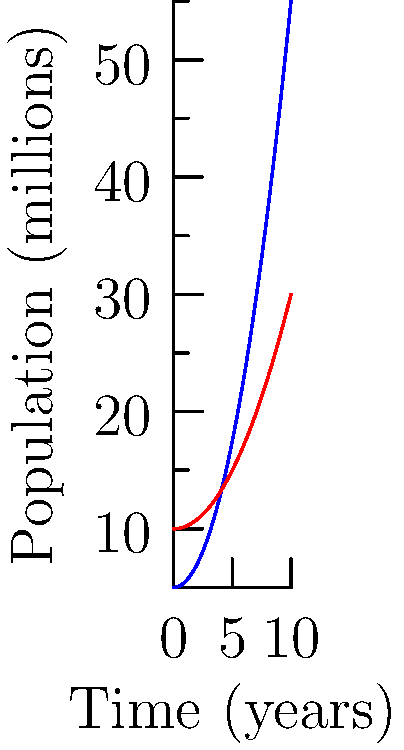The graph shows the population growth of two countries over a 10-year period. Country A's population function is given by $P_1(t) = 5 + 0.5t^2$, and Country B's is $P_2(t) = 10 + 0.2t^2$, where $t$ is time in years and $P$ is population in millions. Calculate the difference in total population growth between Country A and Country B over the 10-year period. To solve this problem, we need to:

1. Calculate the total population growth for each country.
2. Find the difference between these growths.

For each country, the total population growth is the area under its curve from $t=0$ to $t=10$.

For Country A:
1. The area is given by the definite integral: 
   $$\int_0^{10} (5 + 0.5t^2) dt$$
2. Integrate: 
   $$[5t + \frac{0.5t^3}{3}]_0^{10}$$
3. Evaluate: 
   $$(50 + \frac{500}{3}) - (0 + 0) = 50 + \frac{500}{3} = \frac{650}{3}$$

For Country B:
1. The area is given by the definite integral: 
   $$\int_0^{10} (10 + 0.2t^2) dt$$
2. Integrate: 
   $$[10t + \frac{0.2t^3}{3}]_0^{10}$$
3. Evaluate: 
   $$(100 + \frac{200}{3}) - (0 + 0) = 100 + \frac{200}{3} = \frac{400}{3}$$

The difference in growth:
$$\frac{650}{3} - \frac{400}{3} = \frac{250}{3} \approx 83.33$$

Therefore, the difference in total population growth between Country A and Country B over the 10-year period is approximately 83.33 million.
Answer: $\frac{250}{3}$ million or approximately 83.33 million 